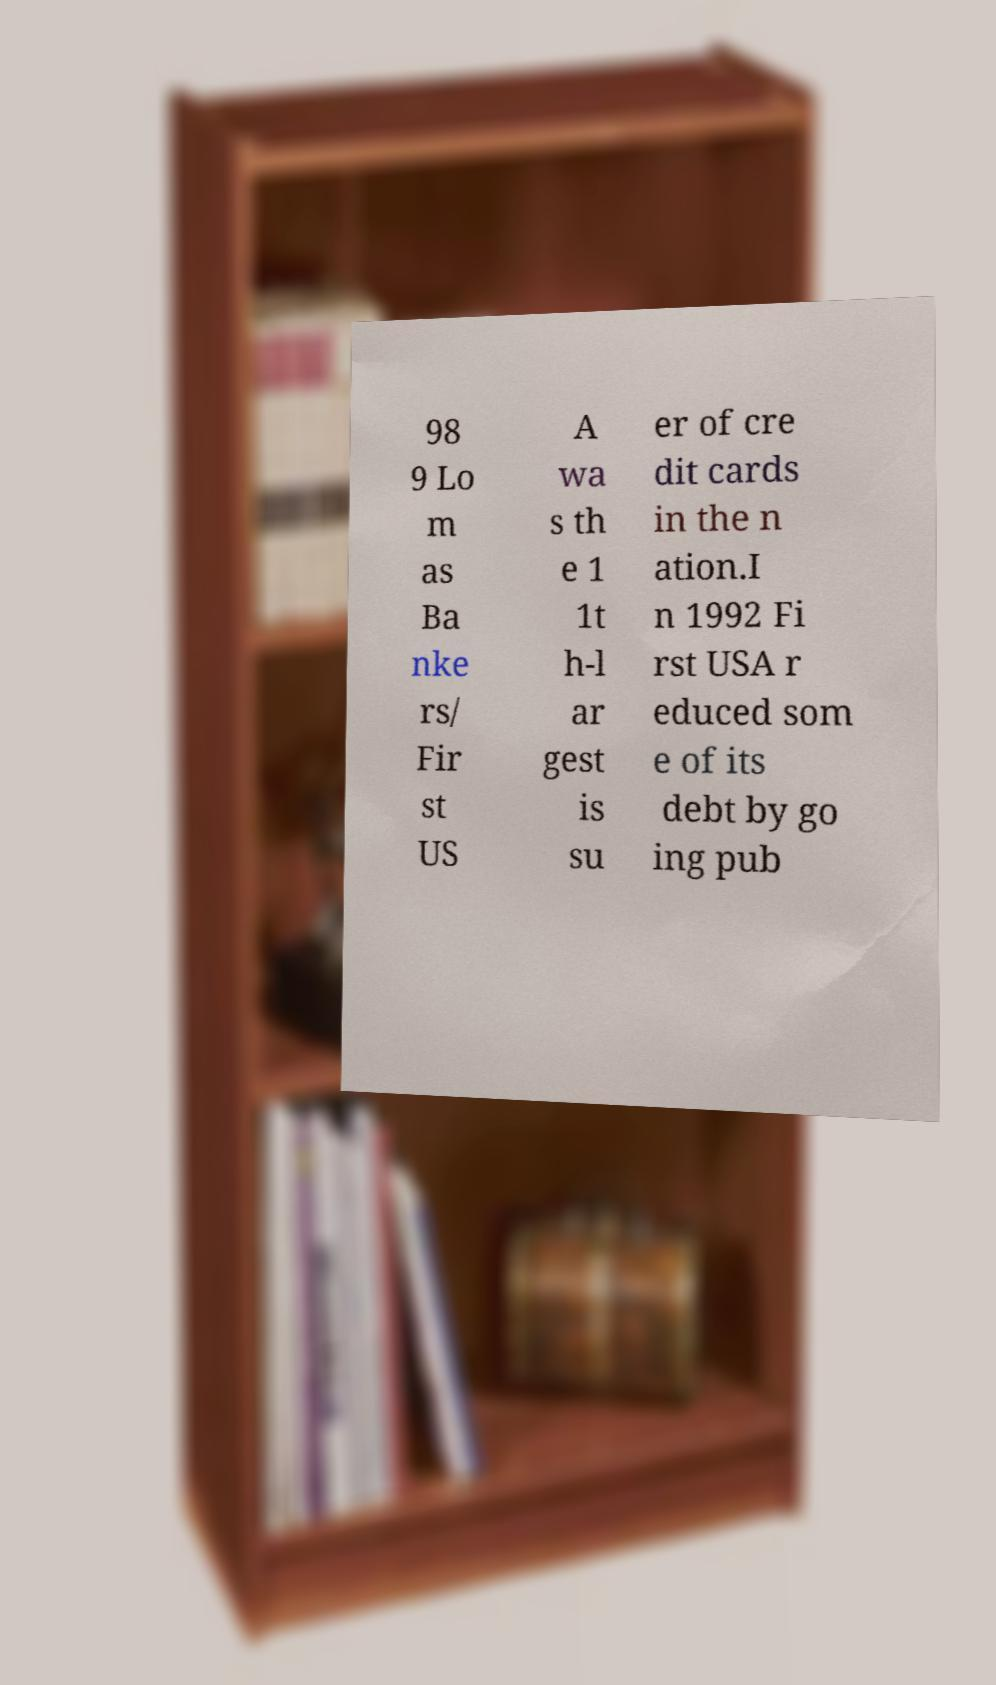Could you assist in decoding the text presented in this image and type it out clearly? 98 9 Lo m as Ba nke rs/ Fir st US A wa s th e 1 1t h-l ar gest is su er of cre dit cards in the n ation.I n 1992 Fi rst USA r educed som e of its debt by go ing pub 